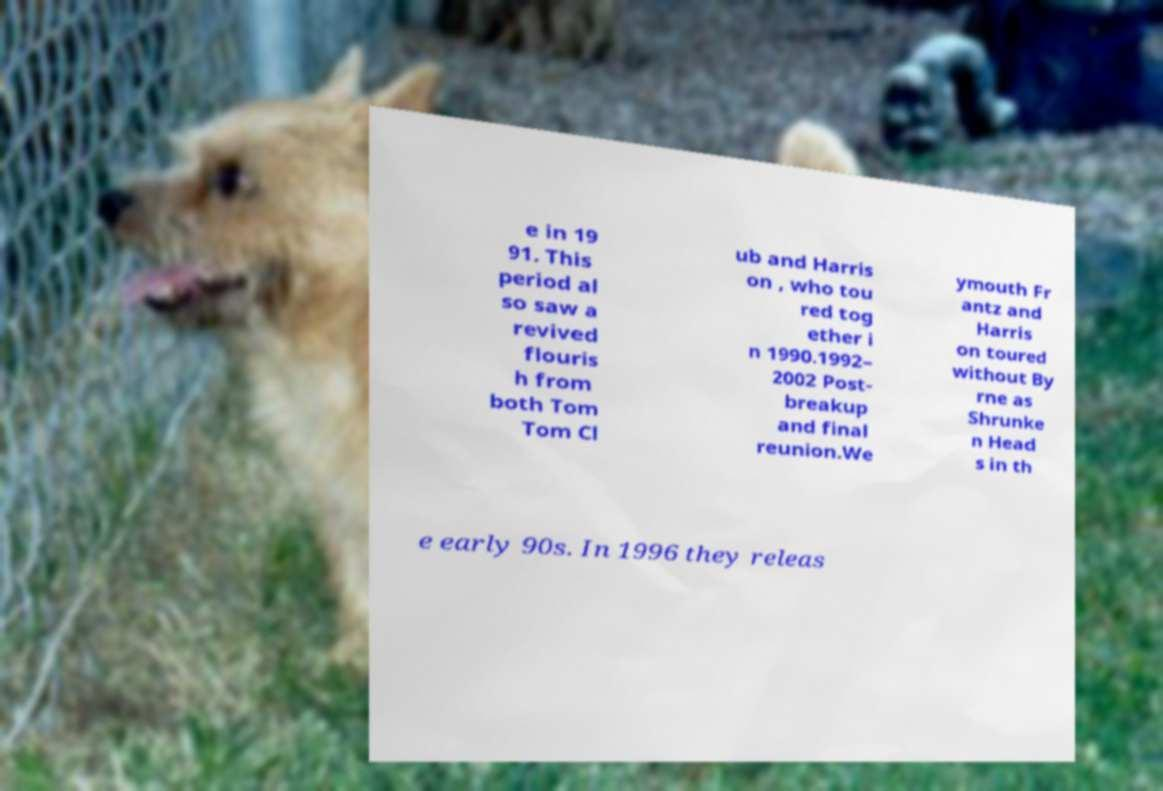For documentation purposes, I need the text within this image transcribed. Could you provide that? e in 19 91. This period al so saw a revived flouris h from both Tom Tom Cl ub and Harris on , who tou red tog ether i n 1990.1992– 2002 Post- breakup and final reunion.We ymouth Fr antz and Harris on toured without By rne as Shrunke n Head s in th e early 90s. In 1996 they releas 